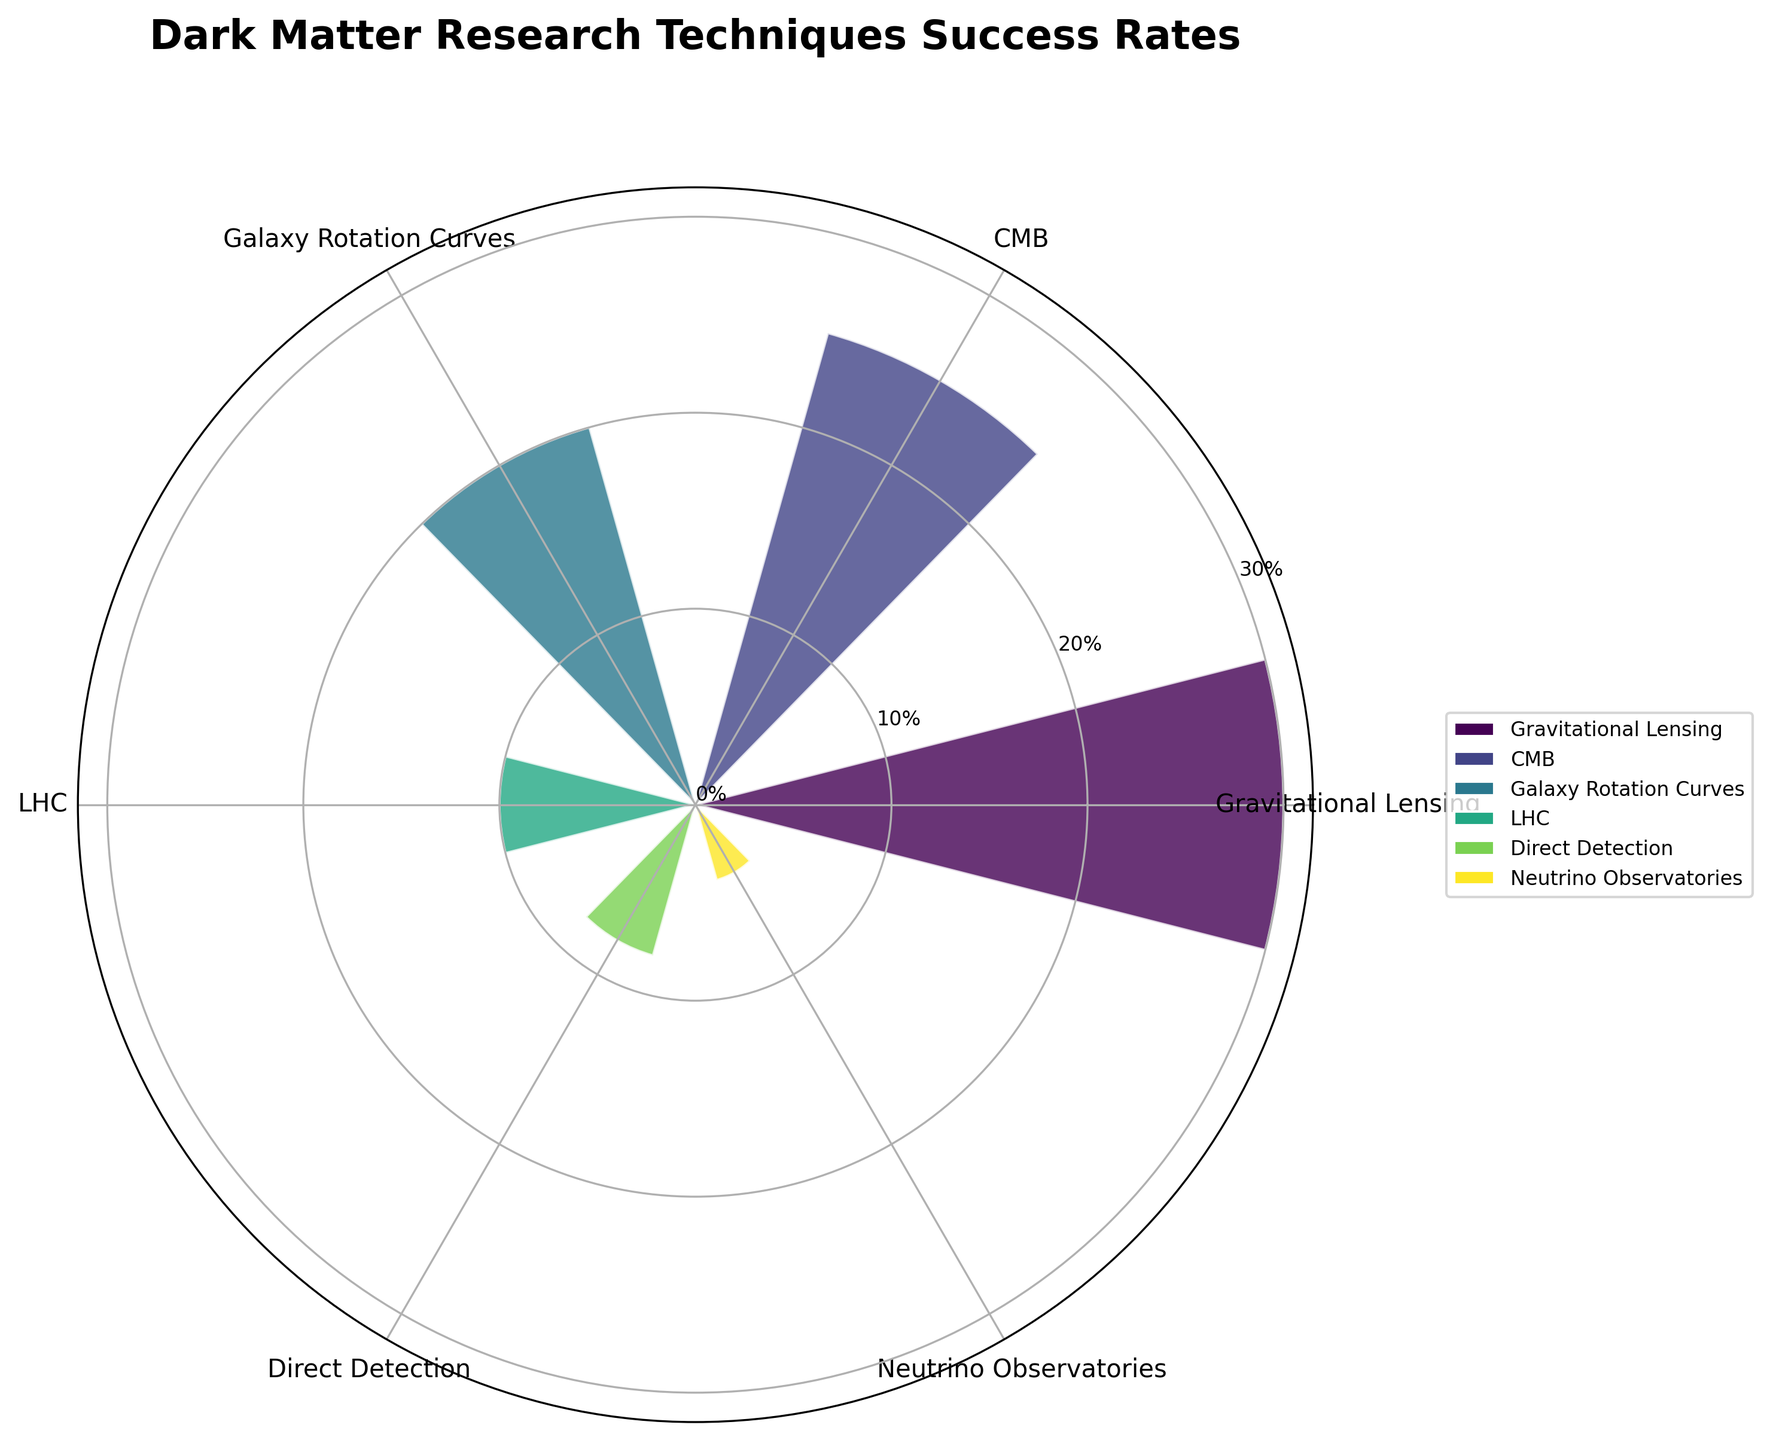Which dark matter research technique has the highest success rate? The darkest bar (representing the longest bar on the chart) corresponds to the technique of Gravitational Lensing, which has the highest success rate.
Answer: Gravitational Lensing How many research techniques have a success rate of 20% or higher? By examining the bars on the polar plot with success rates of 20% or higher (i.e., 30% for Gravitational Lensing, 25% for CMB, and 20% for Galaxy Rotation Curves), we find there are three techniques that meet this criterion.
Answer: Three What is the total success rate of techniques that have less than a 10% success rate? Summing up the success rates of techniques with less than 10% success rate, which are Direct Detection Experiments (8%) and Neutrino Observatories (4%), we get 8% + 4% = 12%.
Answer: 12% How does the success rate of the Large Hadron Collider compare to that of Galaxy Rotation Curves? The Large Hadron Collider has a success rate of 10%, while Galaxy Rotation Curves have a success rate of 20%. Therefore, the Large Hadron Collider's success rate is 10% less than that of Galaxy Rotation Curves.
Answer: 10% less Which technique has the lowest success rate? The shortest bar on the chart denotes the technique of Neutrino Observatories, which has the lowest success rate.
Answer: Neutrino Observatories What is the average success rate of the top three techniques? The top three techniques by success rate are Gravitational Lensing (30%), CMB (25%), and Galaxy Rotation Curves (20%). The average success rate is calculated as (30 + 25 + 20)/3 = 25%.
Answer: 25% Which techniques have a success rate between 5% and 15%? The techniques with success rates falling between 5% and 15% are Direct Detection Experiments (8%) and the Large Hadron Collider (10%).
Answer: Direct Detection Experiments and Large Hadron Collider By how much does the success rate of the CMB exceed that of Direct Detection Experiments? The success rate of CMB is 25%, while that of Direct Detection Experiments is 8%. The difference in their success rates is 25% - 8% = 17%.
Answer: 17% What is the combined success rate of the techniques whose success rates are above the average success rate of all techniques? The techniques above the average success rate (which is (30 + 25 + 20 + 10 + 8 + 4)/6 = 16.17%) are Gravitational Lensing, CMB, and Galaxy Rotation Curves, with success rates of 30%, 25%, and 20% respectively. The combined success rate of these techniques is 30% + 25% + 20% = 75%.
Answer: 75% 